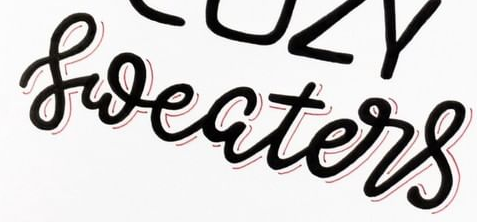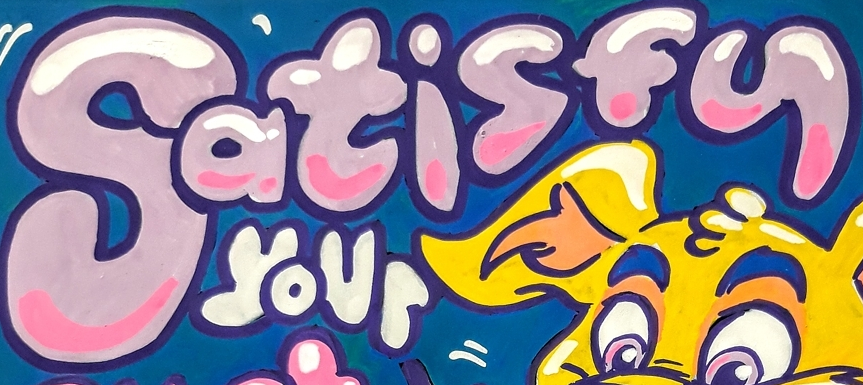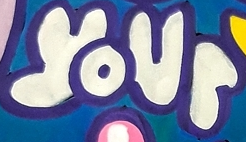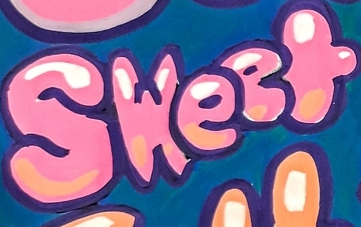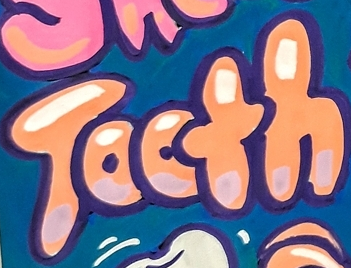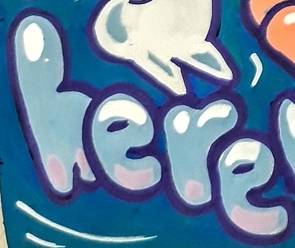What words can you see in these images in sequence, separated by a semicolon? sweaters; Satisfy; your; Sweet; Tooth; here 